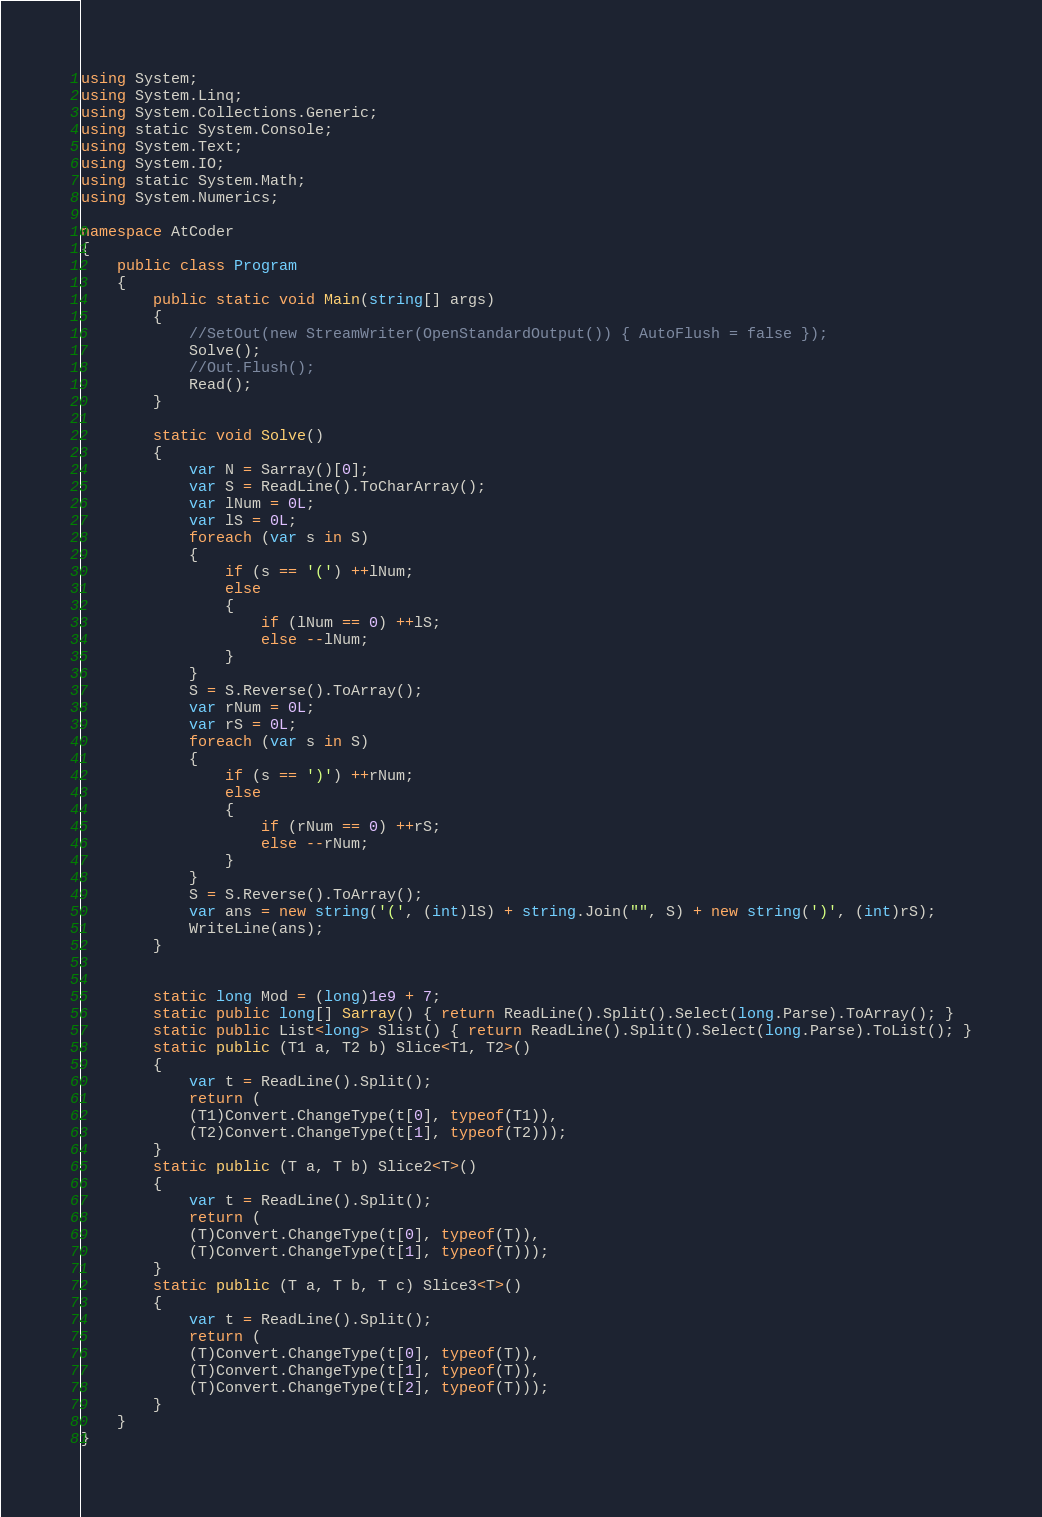<code> <loc_0><loc_0><loc_500><loc_500><_C#_>using System;
using System.Linq;
using System.Collections.Generic;
using static System.Console;
using System.Text;
using System.IO;
using static System.Math;
using System.Numerics;

namespace AtCoder
{
    public class Program
    {
        public static void Main(string[] args)
        {
            //SetOut(new StreamWriter(OpenStandardOutput()) { AutoFlush = false });
            Solve();
            //Out.Flush();
            Read();
        }

        static void Solve()
        {
            var N = Sarray()[0];
            var S = ReadLine().ToCharArray();
            var lNum = 0L;
            var lS = 0L;
            foreach (var s in S)
            {
                if (s == '(') ++lNum;
                else
                {
                    if (lNum == 0) ++lS; 
                    else --lNum;
                }
            }
            S = S.Reverse().ToArray();
            var rNum = 0L;
            var rS = 0L;
            foreach (var s in S)
            {
                if (s == ')') ++rNum;
                else
                {
                    if (rNum == 0) ++rS;
                    else --rNum;
                }
            }
            S = S.Reverse().ToArray();
            var ans = new string('(', (int)lS) + string.Join("", S) + new string(')', (int)rS);
            WriteLine(ans);
        }


        static long Mod = (long)1e9 + 7;
        static public long[] Sarray() { return ReadLine().Split().Select(long.Parse).ToArray(); }
        static public List<long> Slist() { return ReadLine().Split().Select(long.Parse).ToList(); }
        static public (T1 a, T2 b) Slice<T1, T2>()
        {
            var t = ReadLine().Split();
            return (
            (T1)Convert.ChangeType(t[0], typeof(T1)),
            (T2)Convert.ChangeType(t[1], typeof(T2)));
        }
        static public (T a, T b) Slice2<T>()
        {
            var t = ReadLine().Split();
            return (
            (T)Convert.ChangeType(t[0], typeof(T)),
            (T)Convert.ChangeType(t[1], typeof(T)));
        }
        static public (T a, T b, T c) Slice3<T>()
        {
            var t = ReadLine().Split();
            return (
            (T)Convert.ChangeType(t[0], typeof(T)),
            (T)Convert.ChangeType(t[1], typeof(T)),
            (T)Convert.ChangeType(t[2], typeof(T)));
        }
    }
}</code> 